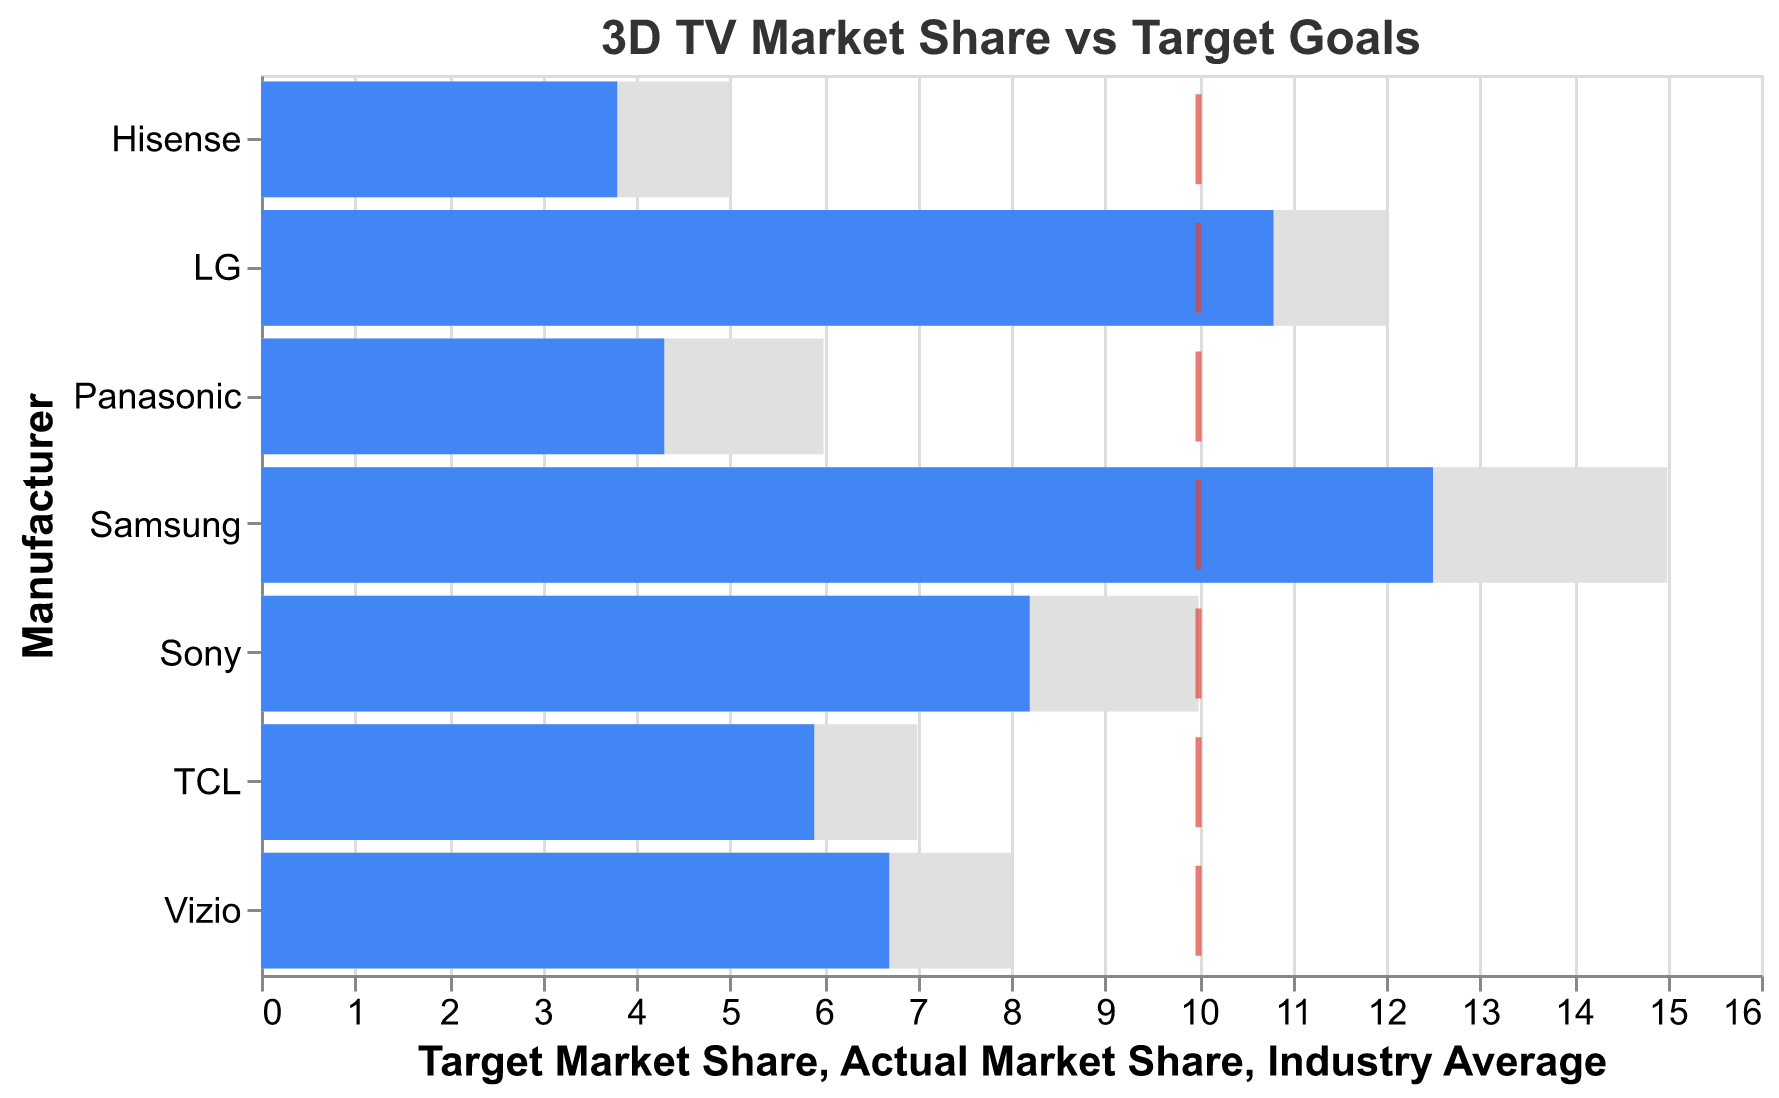what is the title of the figure? The title is usually located at the top of the figure. In this case, it is "3D TV Market Share vs Target Goals".
Answer: 3D TV Market Share vs Target Goals How many manufacturers are included in the chart? By counting the number of different manufacturer names listed on the y-axis, we find there are seven manufacturers.
Answer: 7 Which manufacturer has the highest actual market share? By looking at the heights of the blue bars (representing actual market share), we identify that Samsung has the highest actual market share at 12.5%.
Answer: Samsung What's the average target market share for all manufacturers? To find the average target market share, sum up all the target market shares (15 + 12 + 10 + 8 + 7 + 6 + 5) and divide by the number of manufacturers (7). This equals 63/7 = 9.
Answer: 9 Which manufacturers have actual market shares below the industry average? The red ticks represent the industry average. We compare the height of the blue bars representing actual market shares against the red line, identifying Sony, Vizio, TCL, Panasonic, and Hisense as below the industry average of 10%.
Answer: Sony, Vizio, TCL, Panasonic, Hisense What is the difference between Samsung's actual market share and its target market share? Subtract Samsung's actual market share from its target market share: 15% - 12.5% = 2.5%.
Answer: 2.5% Do any manufacturers exceed their target market share? By comparing the length of blue bars (actual market share) to gray bars (target market share), none of the manufacturers exceed their target market share.
Answer: No Which manufacturer has the smallest difference between actual and target market share? Calculate the differences for each manufacturer: Samsung (2.5%), LG (1.2%), Sony (1.8%), Vizio (1.3%), TCL (1.1%), Panasonic (1.7%), Hisense (1.2%). TCL has the smallest difference at 1.1%.
Answer: TCL Who has the lowest actual market share? Observing the blue bars, Hisense has the lowest actual market share at 3.8%.
Answer: Hisense How does Sony's actual market share compare to LG's? Sony has an actual market share of 8.2%, while LG has 10.8%. Thus, LG’s actual market share is higher than Sony’s.
Answer: LG has a higher market share 